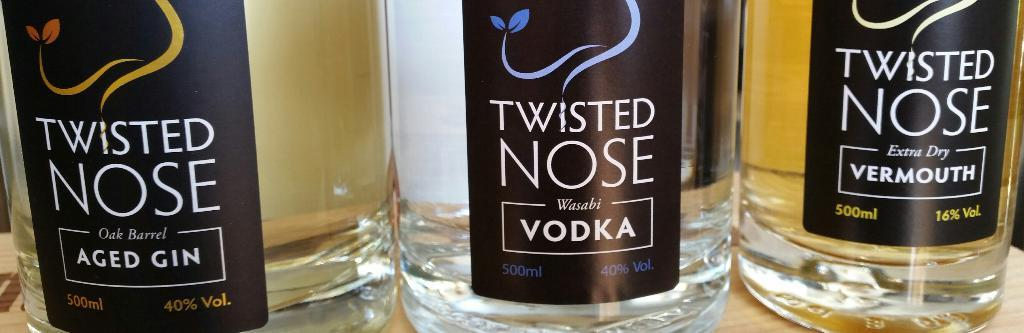<image>
Relay a brief, clear account of the picture shown. Three bottles of Twisted Nose alcohol include an aged gin, vodka and vermouth. 